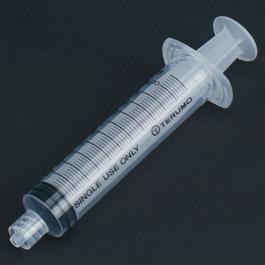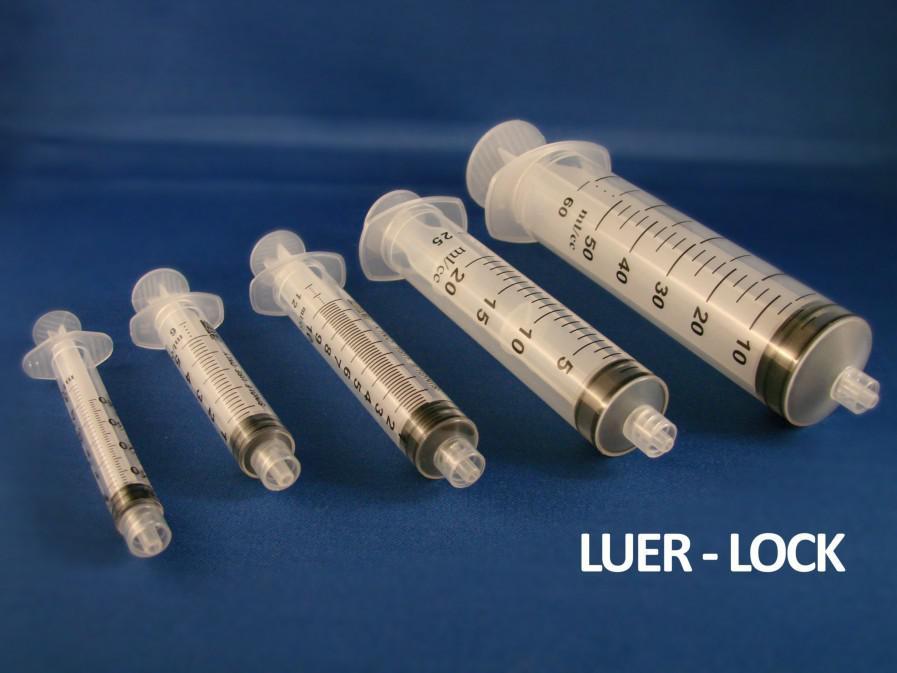The first image is the image on the left, the second image is the image on the right. Examine the images to the left and right. Is the description "The left image has at least six syringes" accurate? Answer yes or no. No. The first image is the image on the left, the second image is the image on the right. For the images displayed, is the sentence "The right image shows a single syringe angled with its tip at the lower right." factually correct? Answer yes or no. No. 